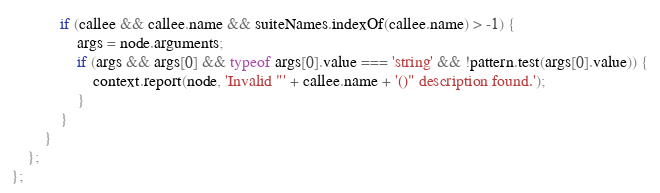Convert code to text. <code><loc_0><loc_0><loc_500><loc_500><_JavaScript_>
            if (callee && callee.name && suiteNames.indexOf(callee.name) > -1) {
                args = node.arguments;
                if (args && args[0] && typeof args[0].value === 'string' && !pattern.test(args[0].value)) {
                    context.report(node, 'Invalid "' + callee.name + '()" description found.');
                }
            }
        }
    };
};
</code> 